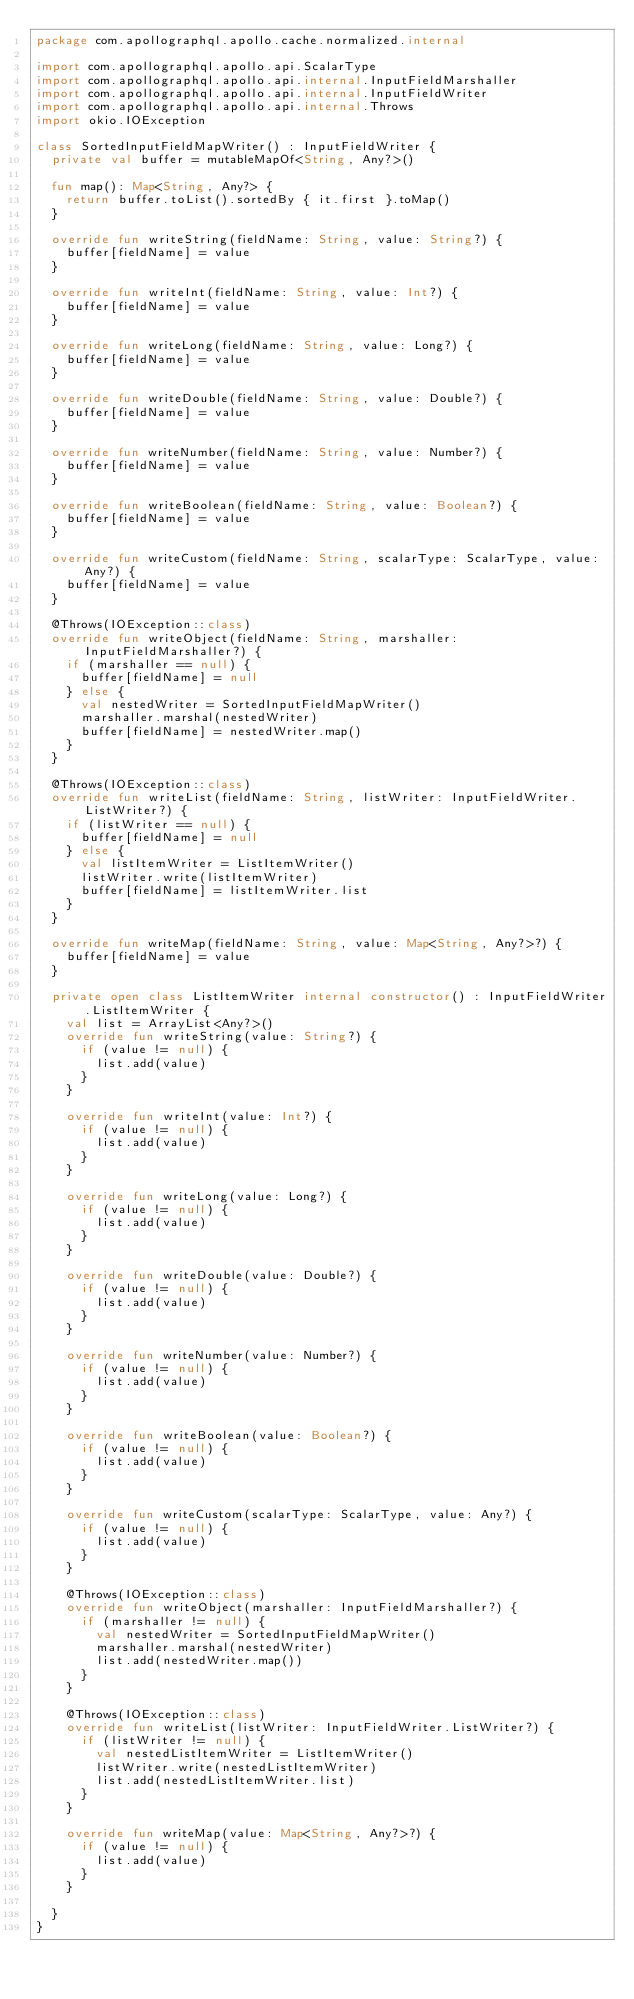<code> <loc_0><loc_0><loc_500><loc_500><_Kotlin_>package com.apollographql.apollo.cache.normalized.internal

import com.apollographql.apollo.api.ScalarType
import com.apollographql.apollo.api.internal.InputFieldMarshaller
import com.apollographql.apollo.api.internal.InputFieldWriter
import com.apollographql.apollo.api.internal.Throws
import okio.IOException

class SortedInputFieldMapWriter() : InputFieldWriter {
  private val buffer = mutableMapOf<String, Any?>()

  fun map(): Map<String, Any?> {
    return buffer.toList().sortedBy { it.first }.toMap()
  }

  override fun writeString(fieldName: String, value: String?) {
    buffer[fieldName] = value
  }

  override fun writeInt(fieldName: String, value: Int?) {
    buffer[fieldName] = value
  }

  override fun writeLong(fieldName: String, value: Long?) {
    buffer[fieldName] = value
  }

  override fun writeDouble(fieldName: String, value: Double?) {
    buffer[fieldName] = value
  }

  override fun writeNumber(fieldName: String, value: Number?) {
    buffer[fieldName] = value
  }

  override fun writeBoolean(fieldName: String, value: Boolean?) {
    buffer[fieldName] = value
  }

  override fun writeCustom(fieldName: String, scalarType: ScalarType, value: Any?) {
    buffer[fieldName] = value
  }

  @Throws(IOException::class)
  override fun writeObject(fieldName: String, marshaller: InputFieldMarshaller?) {
    if (marshaller == null) {
      buffer[fieldName] = null
    } else {
      val nestedWriter = SortedInputFieldMapWriter()
      marshaller.marshal(nestedWriter)
      buffer[fieldName] = nestedWriter.map()
    }
  }

  @Throws(IOException::class)
  override fun writeList(fieldName: String, listWriter: InputFieldWriter.ListWriter?) {
    if (listWriter == null) {
      buffer[fieldName] = null
    } else {
      val listItemWriter = ListItemWriter()
      listWriter.write(listItemWriter)
      buffer[fieldName] = listItemWriter.list
    }
  }

  override fun writeMap(fieldName: String, value: Map<String, Any?>?) {
    buffer[fieldName] = value
  }

  private open class ListItemWriter internal constructor() : InputFieldWriter.ListItemWriter {
    val list = ArrayList<Any?>()
    override fun writeString(value: String?) {
      if (value != null) {
        list.add(value)
      }
    }

    override fun writeInt(value: Int?) {
      if (value != null) {
        list.add(value)
      }
    }

    override fun writeLong(value: Long?) {
      if (value != null) {
        list.add(value)
      }
    }

    override fun writeDouble(value: Double?) {
      if (value != null) {
        list.add(value)
      }
    }

    override fun writeNumber(value: Number?) {
      if (value != null) {
        list.add(value)
      }
    }

    override fun writeBoolean(value: Boolean?) {
      if (value != null) {
        list.add(value)
      }
    }

    override fun writeCustom(scalarType: ScalarType, value: Any?) {
      if (value != null) {
        list.add(value)
      }
    }

    @Throws(IOException::class)
    override fun writeObject(marshaller: InputFieldMarshaller?) {
      if (marshaller != null) {
        val nestedWriter = SortedInputFieldMapWriter()
        marshaller.marshal(nestedWriter)
        list.add(nestedWriter.map())
      }
    }

    @Throws(IOException::class)
    override fun writeList(listWriter: InputFieldWriter.ListWriter?) {
      if (listWriter != null) {
        val nestedListItemWriter = ListItemWriter()
        listWriter.write(nestedListItemWriter)
        list.add(nestedListItemWriter.list)
      }
    }

    override fun writeMap(value: Map<String, Any?>?) {
      if (value != null) {
        list.add(value)
      }
    }

  }
}</code> 